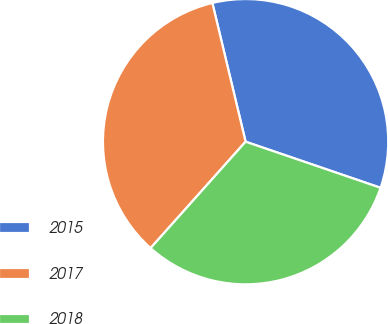<chart> <loc_0><loc_0><loc_500><loc_500><pie_chart><fcel>2015<fcel>2017<fcel>2018<nl><fcel>33.98%<fcel>34.66%<fcel>31.36%<nl></chart> 